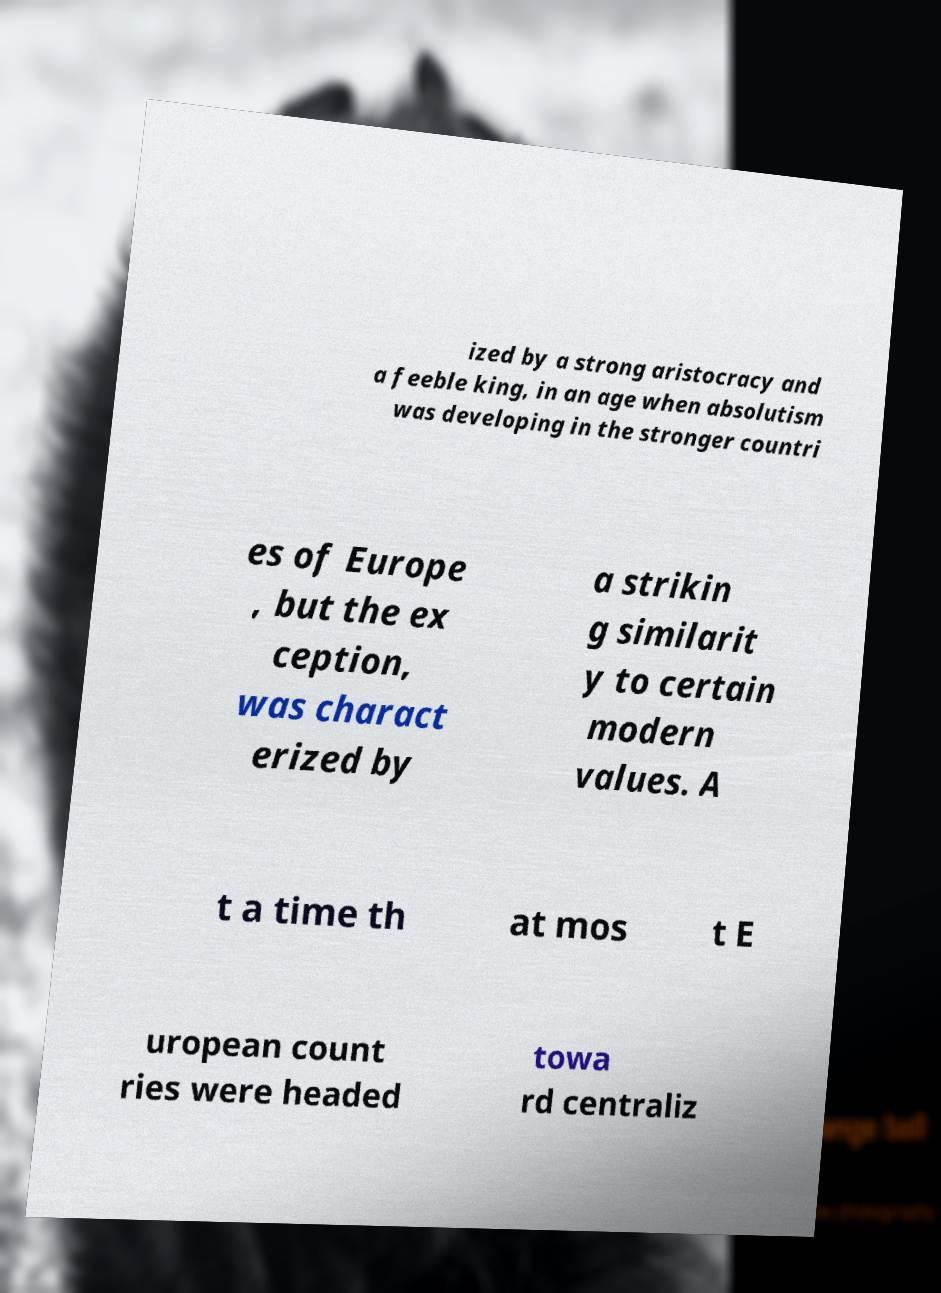Please read and relay the text visible in this image. What does it say? ized by a strong aristocracy and a feeble king, in an age when absolutism was developing in the stronger countri es of Europe , but the ex ception, was charact erized by a strikin g similarit y to certain modern values. A t a time th at mos t E uropean count ries were headed towa rd centraliz 